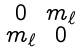<formula> <loc_0><loc_0><loc_500><loc_500>\begin{smallmatrix} 0 & m _ { \ell } \\ m _ { \ell } & 0 \end{smallmatrix}</formula> 